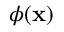Convert formula to latex. <formula><loc_0><loc_0><loc_500><loc_500>\phi ( { x } )</formula> 